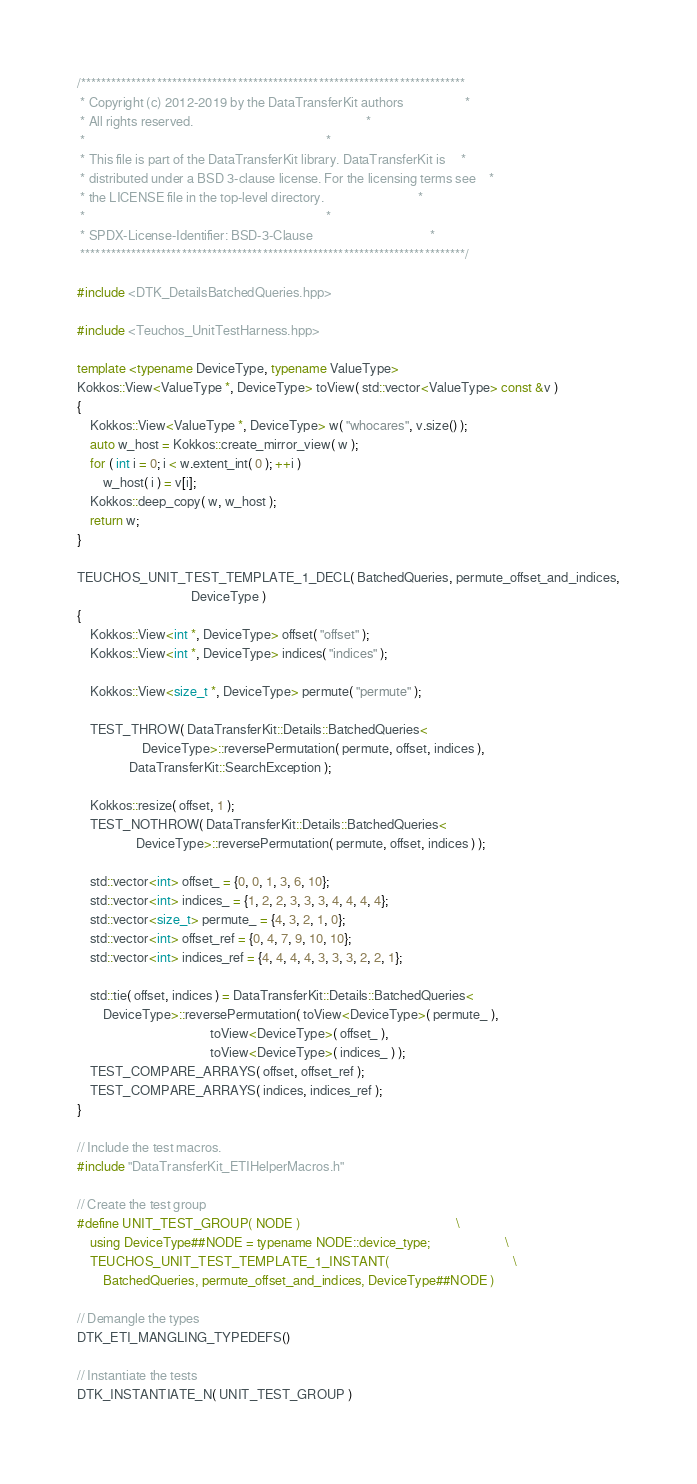Convert code to text. <code><loc_0><loc_0><loc_500><loc_500><_C++_>/****************************************************************************
 * Copyright (c) 2012-2019 by the DataTransferKit authors                   *
 * All rights reserved.                                                     *
 *                                                                          *
 * This file is part of the DataTransferKit library. DataTransferKit is     *
 * distributed under a BSD 3-clause license. For the licensing terms see    *
 * the LICENSE file in the top-level directory.                             *
 *                                                                          *
 * SPDX-License-Identifier: BSD-3-Clause                                    *
 ****************************************************************************/

#include <DTK_DetailsBatchedQueries.hpp>

#include <Teuchos_UnitTestHarness.hpp>

template <typename DeviceType, typename ValueType>
Kokkos::View<ValueType *, DeviceType> toView( std::vector<ValueType> const &v )
{
    Kokkos::View<ValueType *, DeviceType> w( "whocares", v.size() );
    auto w_host = Kokkos::create_mirror_view( w );
    for ( int i = 0; i < w.extent_int( 0 ); ++i )
        w_host( i ) = v[i];
    Kokkos::deep_copy( w, w_host );
    return w;
}

TEUCHOS_UNIT_TEST_TEMPLATE_1_DECL( BatchedQueries, permute_offset_and_indices,
                                   DeviceType )
{
    Kokkos::View<int *, DeviceType> offset( "offset" );
    Kokkos::View<int *, DeviceType> indices( "indices" );

    Kokkos::View<size_t *, DeviceType> permute( "permute" );

    TEST_THROW( DataTransferKit::Details::BatchedQueries<
                    DeviceType>::reversePermutation( permute, offset, indices ),
                DataTransferKit::SearchException );

    Kokkos::resize( offset, 1 );
    TEST_NOTHROW( DataTransferKit::Details::BatchedQueries<
                  DeviceType>::reversePermutation( permute, offset, indices ) );

    std::vector<int> offset_ = {0, 0, 1, 3, 6, 10};
    std::vector<int> indices_ = {1, 2, 2, 3, 3, 3, 4, 4, 4, 4};
    std::vector<size_t> permute_ = {4, 3, 2, 1, 0};
    std::vector<int> offset_ref = {0, 4, 7, 9, 10, 10};
    std::vector<int> indices_ref = {4, 4, 4, 4, 3, 3, 3, 2, 2, 1};

    std::tie( offset, indices ) = DataTransferKit::Details::BatchedQueries<
        DeviceType>::reversePermutation( toView<DeviceType>( permute_ ),
                                         toView<DeviceType>( offset_ ),
                                         toView<DeviceType>( indices_ ) );
    TEST_COMPARE_ARRAYS( offset, offset_ref );
    TEST_COMPARE_ARRAYS( indices, indices_ref );
}

// Include the test macros.
#include "DataTransferKit_ETIHelperMacros.h"

// Create the test group
#define UNIT_TEST_GROUP( NODE )                                                \
    using DeviceType##NODE = typename NODE::device_type;                       \
    TEUCHOS_UNIT_TEST_TEMPLATE_1_INSTANT(                                      \
        BatchedQueries, permute_offset_and_indices, DeviceType##NODE )

// Demangle the types
DTK_ETI_MANGLING_TYPEDEFS()

// Instantiate the tests
DTK_INSTANTIATE_N( UNIT_TEST_GROUP )
</code> 